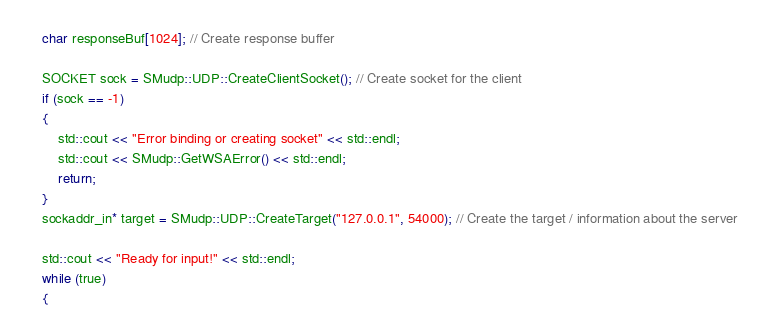Convert code to text. <code><loc_0><loc_0><loc_500><loc_500><_C++_>
	char responseBuf[1024]; // Create response buffer
	
	SOCKET sock = SMudp::UDP::CreateClientSocket(); // Create socket for the client
	if (sock == -1)
	{
		std::cout << "Error binding or creating socket" << std::endl;
		std::cout << SMudp::GetWSAError() << std::endl;
		return; 
	}
	sockaddr_in* target = SMudp::UDP::CreateTarget("127.0.0.1", 54000); // Create the target / information about the server

	std::cout << "Ready for input!" << std::endl;
	while (true)
	{</code> 